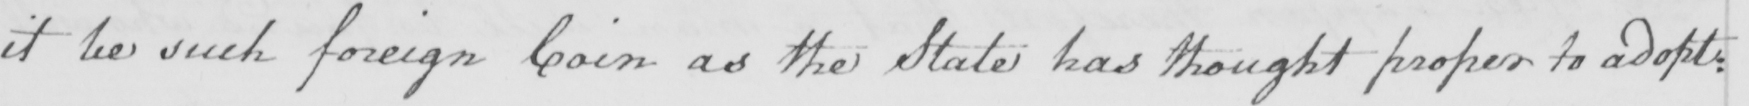What does this handwritten line say? it be such foreign Coin as the State has thought proper to adopt : 